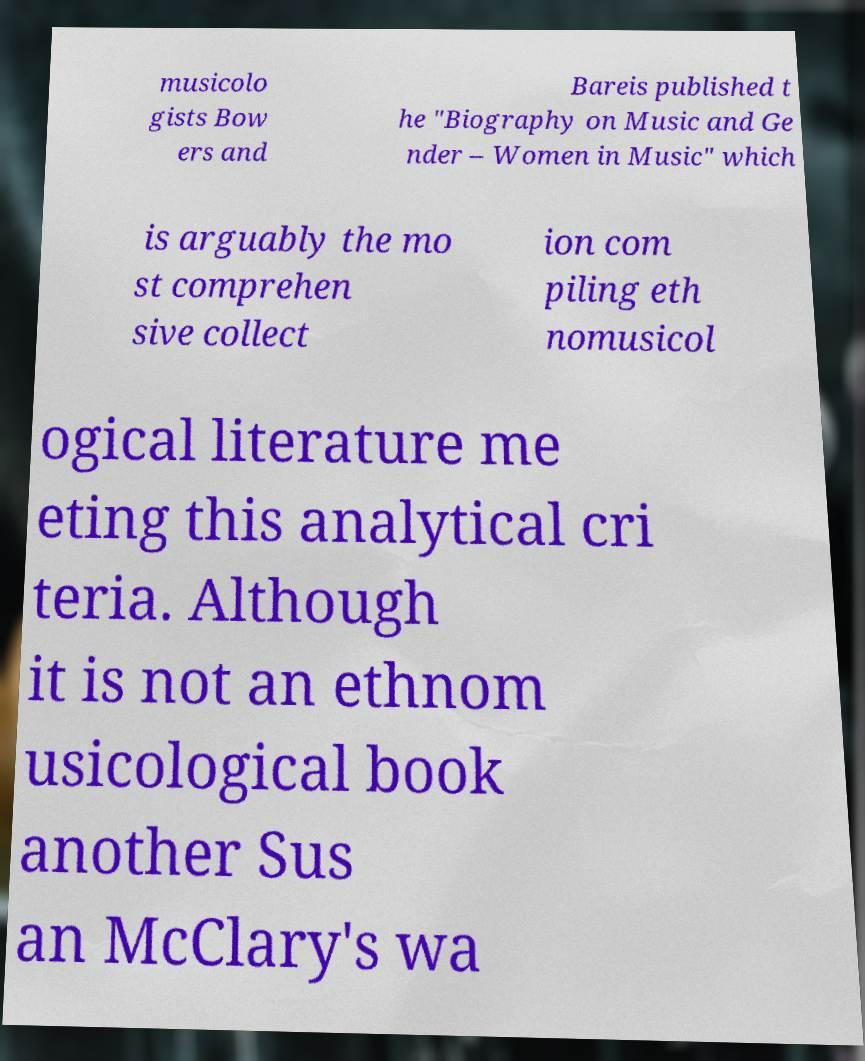I need the written content from this picture converted into text. Can you do that? musicolo gists Bow ers and Bareis published t he "Biography on Music and Ge nder – Women in Music" which is arguably the mo st comprehen sive collect ion com piling eth nomusicol ogical literature me eting this analytical cri teria. Although it is not an ethnom usicological book another Sus an McClary's wa 